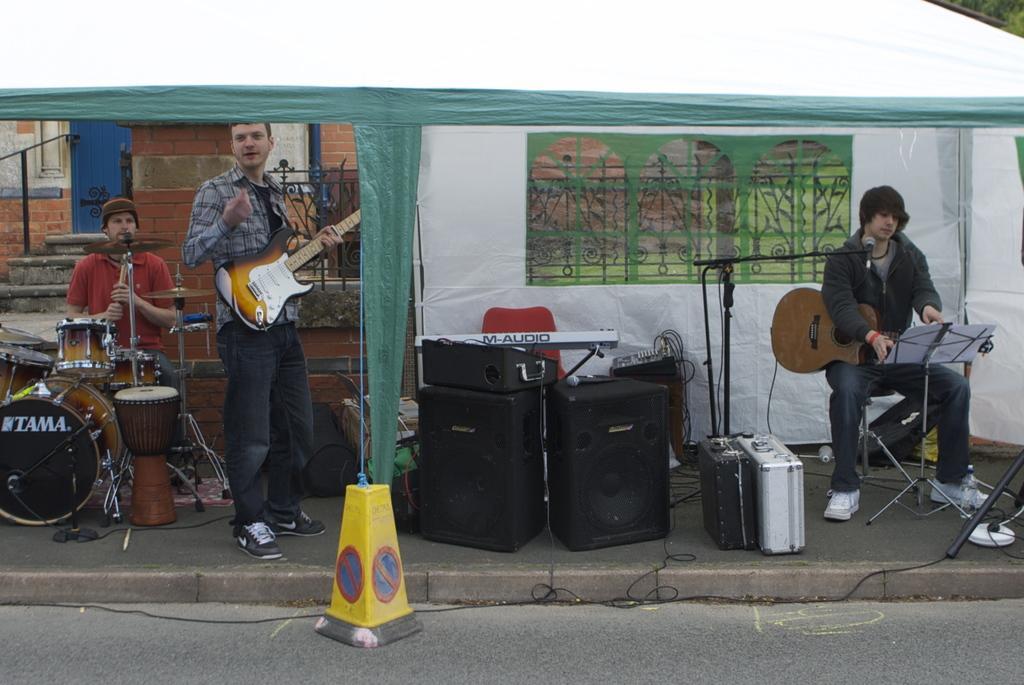In one or two sentences, can you explain what this image depicts? In the given image we can see there are three person, two of them are sitting and one person is standing. These are the musical instruments. This is a sound box. This is a tent under which these persons are performing. 